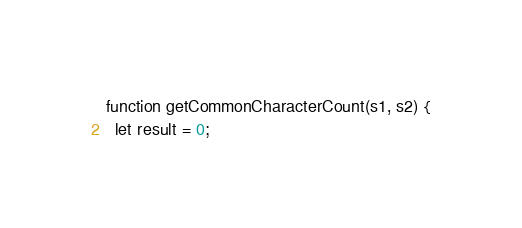Convert code to text. <code><loc_0><loc_0><loc_500><loc_500><_JavaScript_>function getCommonCharacterCount(s1, s2) {
  let result = 0;</code> 